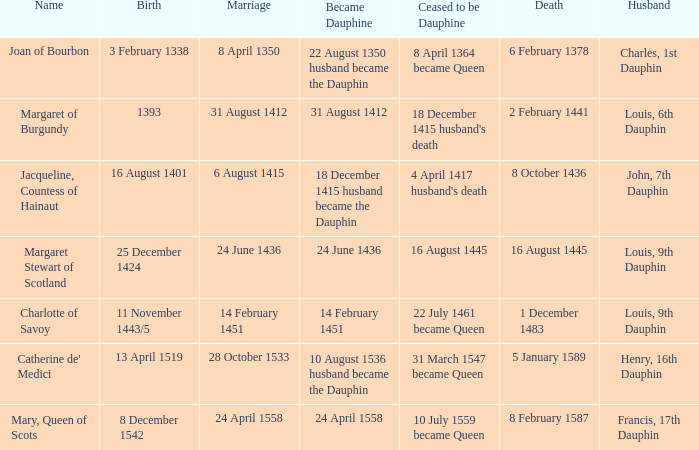Whose birthday is on august 16, 1401? Jacqueline, Countess of Hainaut. 